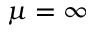Convert formula to latex. <formula><loc_0><loc_0><loc_500><loc_500>\mu = \infty</formula> 